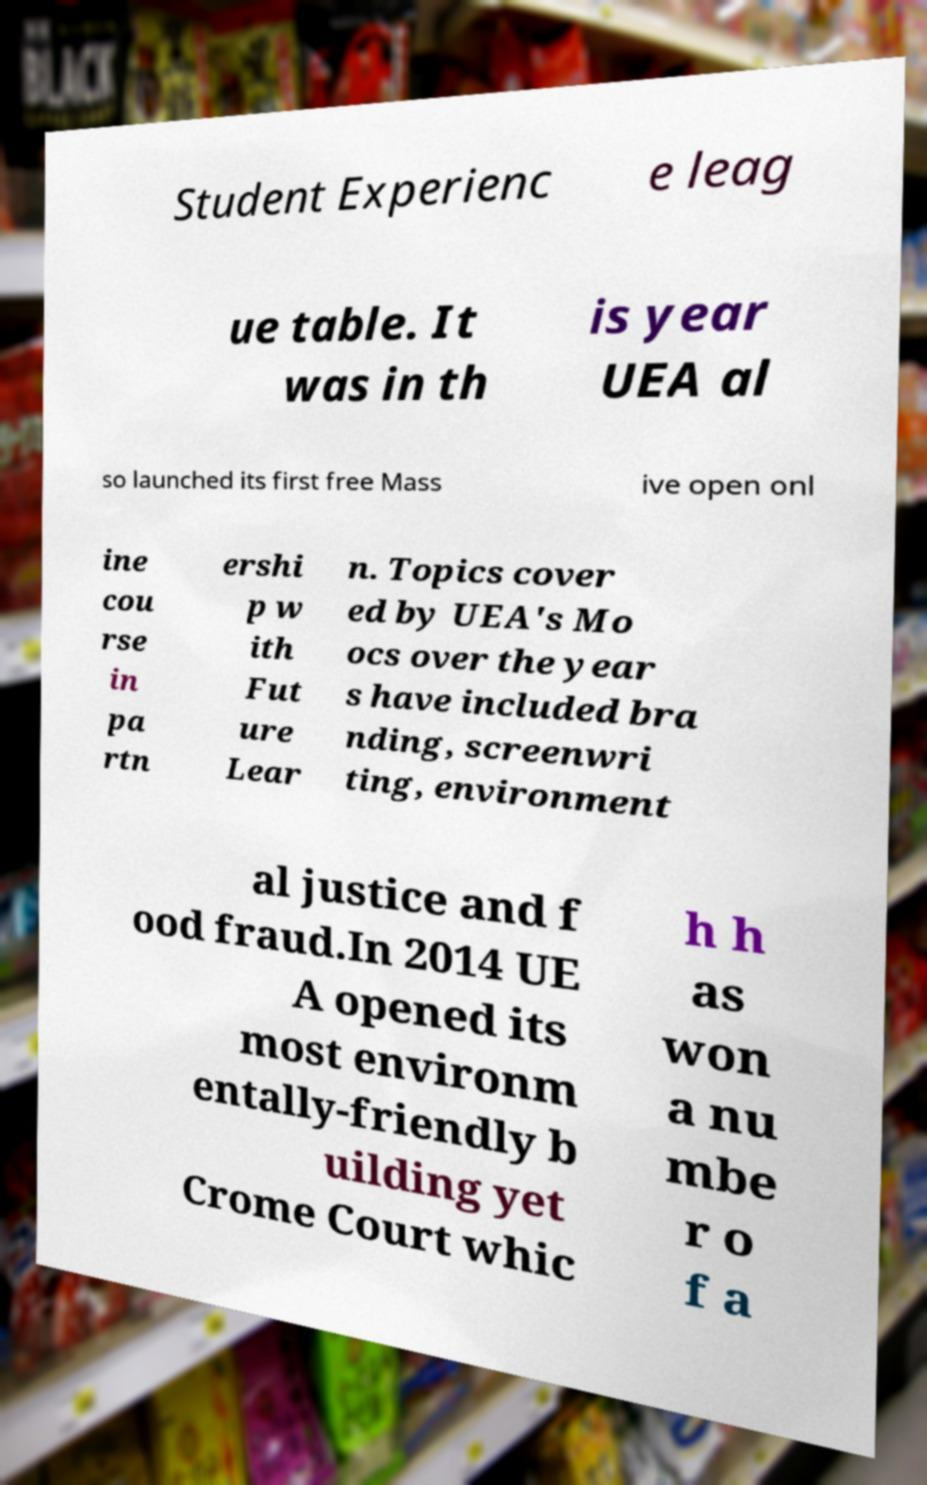I need the written content from this picture converted into text. Can you do that? Student Experienc e leag ue table. It was in th is year UEA al so launched its first free Mass ive open onl ine cou rse in pa rtn ershi p w ith Fut ure Lear n. Topics cover ed by UEA's Mo ocs over the year s have included bra nding, screenwri ting, environment al justice and f ood fraud.In 2014 UE A opened its most environm entally-friendly b uilding yet Crome Court whic h h as won a nu mbe r o f a 